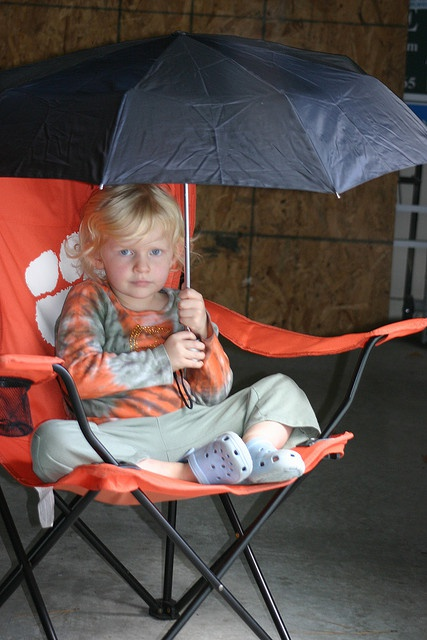Describe the objects in this image and their specific colors. I can see umbrella in black and gray tones, people in black, darkgray, lightgray, brown, and gray tones, and chair in black, gray, salmon, and red tones in this image. 